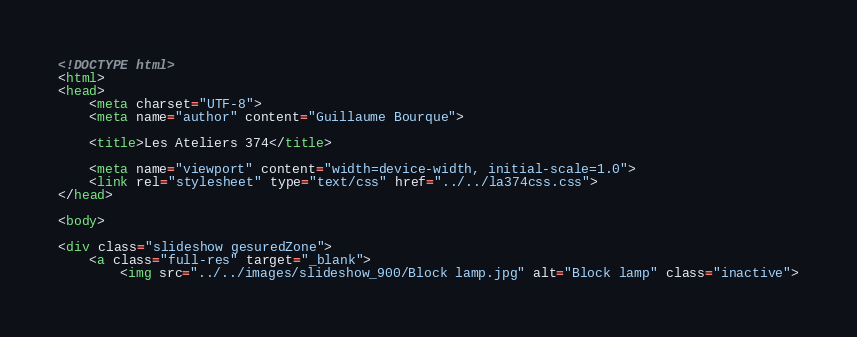Convert code to text. <code><loc_0><loc_0><loc_500><loc_500><_HTML_><!DOCTYPE html>
<html>
<head>
	<meta charset="UTF-8">
	<meta name="author" content="Guillaume Bourque">

	<title>Les Ateliers 374</title>

	<meta name="viewport" content="width=device-width, initial-scale=1.0">
	<link rel="stylesheet" type="text/css" href="../../la374css.css">
</head>

<body>

<div class="slideshow gesuredZone">
	<a class="full-res" target="_blank">
		<img src="../../images/slideshow_900/Block lamp.jpg" alt="Block lamp" class="inactive"></code> 